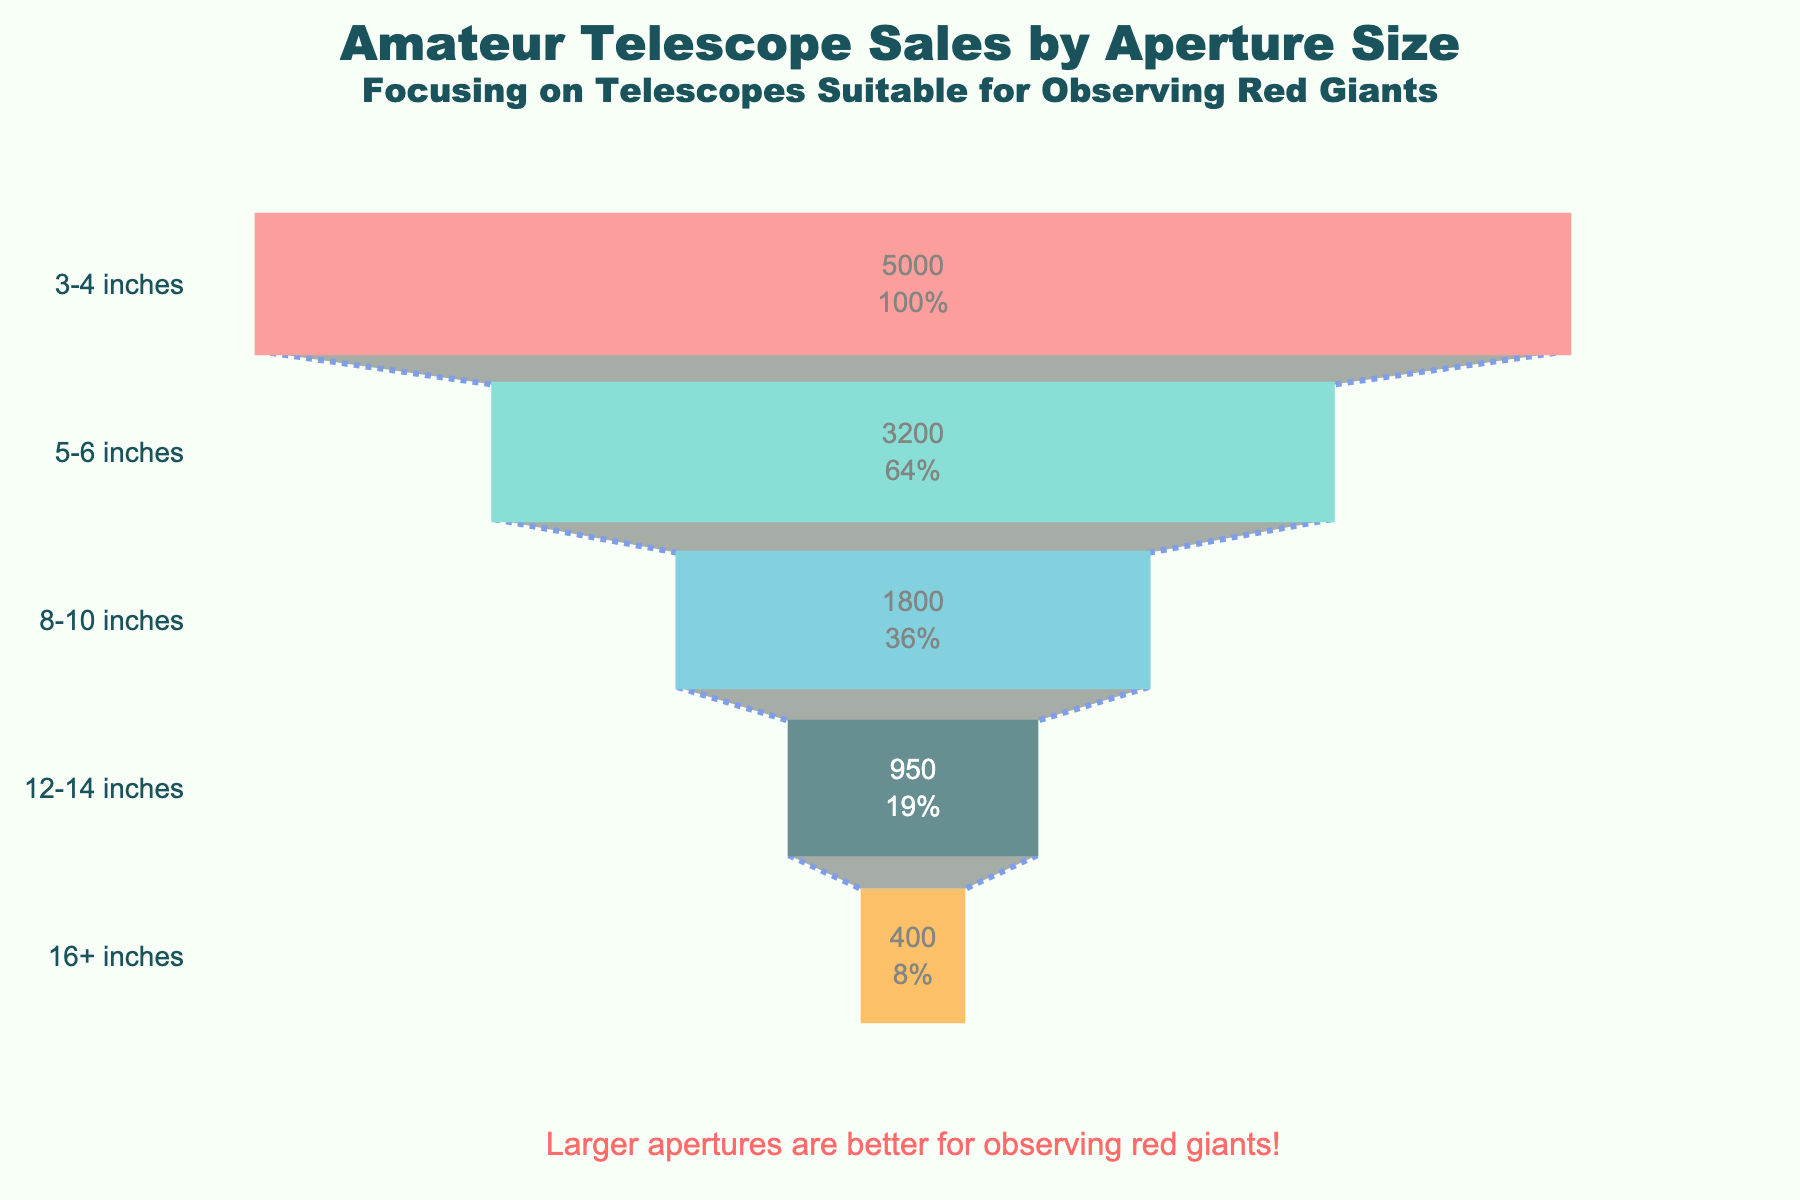Which aperture size has the highest number of telescopes sold? According to the figure, the aperture size with the highest number of telescopes sold is the widest segment at the top. This segment represents the 3-4 inch aperture size, which shows 5000 telescopes sold.
Answer: 3-4 inches Which aperture size accounts for the smallest percentage of telescope sales? Look at the narrowest section at the bottom of the funnel chart. This section represents the 16+ inch aperture size, with only 400 telescopes sold, accounting for the smallest percentage.
Answer: 16+ inches How many telescopes were sold with an aperture size of 8-10 inches? The funnel chart indicates the number of telescopes sold for different aperture sizes. The section for the 8-10 inch aperture size shows 1800 telescopes sold.
Answer: 1800 What is the percentage of telescope sales for the 12-14 inch aperture size? To find this, locate the 12-14 inch section in the funnel chart, then refer to the hover text or annotations that provide percentage information. It shows that 12-14 inch telescopes account for approximately 9.4% of total sales.
Answer: 9.4% Compare the number of telescopes sold between the 5-6 inch and 12-14 inch aperture sizes. The funnel chart displays 3200 telescopes sold for 5-6 inch apertures and 950 for 12-14 inch apertures. By comparing, 3200 is notably larger than 950.
Answer: 3200 vs. 950 What is the difference in the number of telescopes sold between the largest (3-4 inches) and the smallest (16+ inches) aperture sizes? The chart shows 5000 telescopes sold for 3-4 inches and 400 for 16+ inches. The difference is calculated as 5000 - 400.
Answer: 4600 Which aperture size would be most suitable for observing red giants based on sales data? Larger apertures are generally better for observing red giants due to their larger light-gathering capability. Although the smaller apertures had more sales, the 16+ inch telescopes, despite the lowest sales, would be most suitable for observing red giants.
Answer: 16+ inches If a customer is choosing between 8-10 inches and 12-14 inches, how many more 8-10 inch telescopes were sold compared to 12-14 inch? The funnel chart shows 1800 telescopes sold for 8-10 inches and 950 for 12-14 inches. The difference is calculated as 1800 - 950.
Answer: 850 What's the total number of telescopes sold for apertures greater than or equal to 8 inches? Add the number of telescopes sold for 8-10 inches, 12-14 inches, and 16+ inches. The values are 1800, 950, and 400 respectively, so the total is 1800 + 950 + 400.
Answer: 3150 Identify the midpoint of the distribution in terms of the number of telescopes sold. Does it fall within the range of an aperture size specifically? The total sales are 11350. The midpoint (median) in the distribution of telescopes sold is around the 5680 mark. Checking against the cumulative sales, the 5-6 inch range with a cumulative 8200 sales encompasses this midpoint, indicating it falls within this range.
Answer: 5-6 inches 